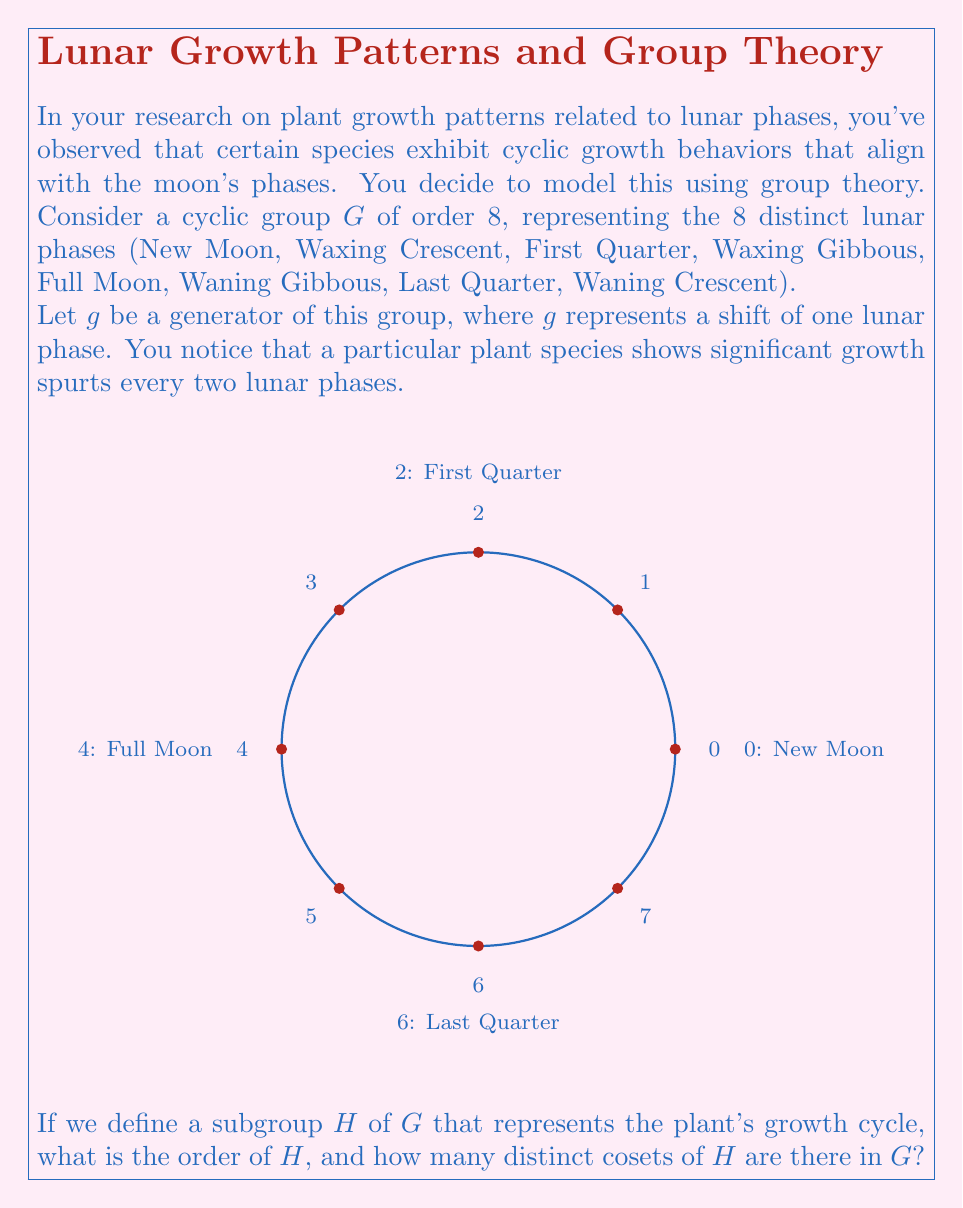Provide a solution to this math problem. Let's approach this step-by-step:

1) First, we need to understand what the subgroup $H$ represents. The plant shows growth spurts every two lunar phases, which means $H$ is generated by $g^2$.

2) To find the order of $H$, we need to determine how many elements are in the subgroup generated by $g^2$:

   $H = \{e, g^2, g^4, g^6\}$

   Where $e$ is the identity element (no phase shift), $g^2$ is a shift of two phases, $g^4$ is a shift of four phases, and $g^6$ is a shift of six phases.

3) Counting these elements, we see that the order of $H$ is 4.

4) To find the number of distinct cosets of $H$ in $G$, we can use Lagrange's theorem:

   $|G| = |H| \cdot [G:H]$

   Where $|G|$ is the order of $G$, $|H|$ is the order of $H$, and $[G:H]$ is the index of $H$ in $G$ (which is the number of distinct cosets).

5) We know that $|G| = 8$ and $|H| = 4$, so:

   $8 = 4 \cdot [G:H]$

6) Solving for $[G:H]$:

   $[G:H] = 8/4 = 2$

Therefore, there are 2 distinct cosets of $H$ in $G$.
Answer: Order of $H$: 4; Number of distinct cosets: 2 